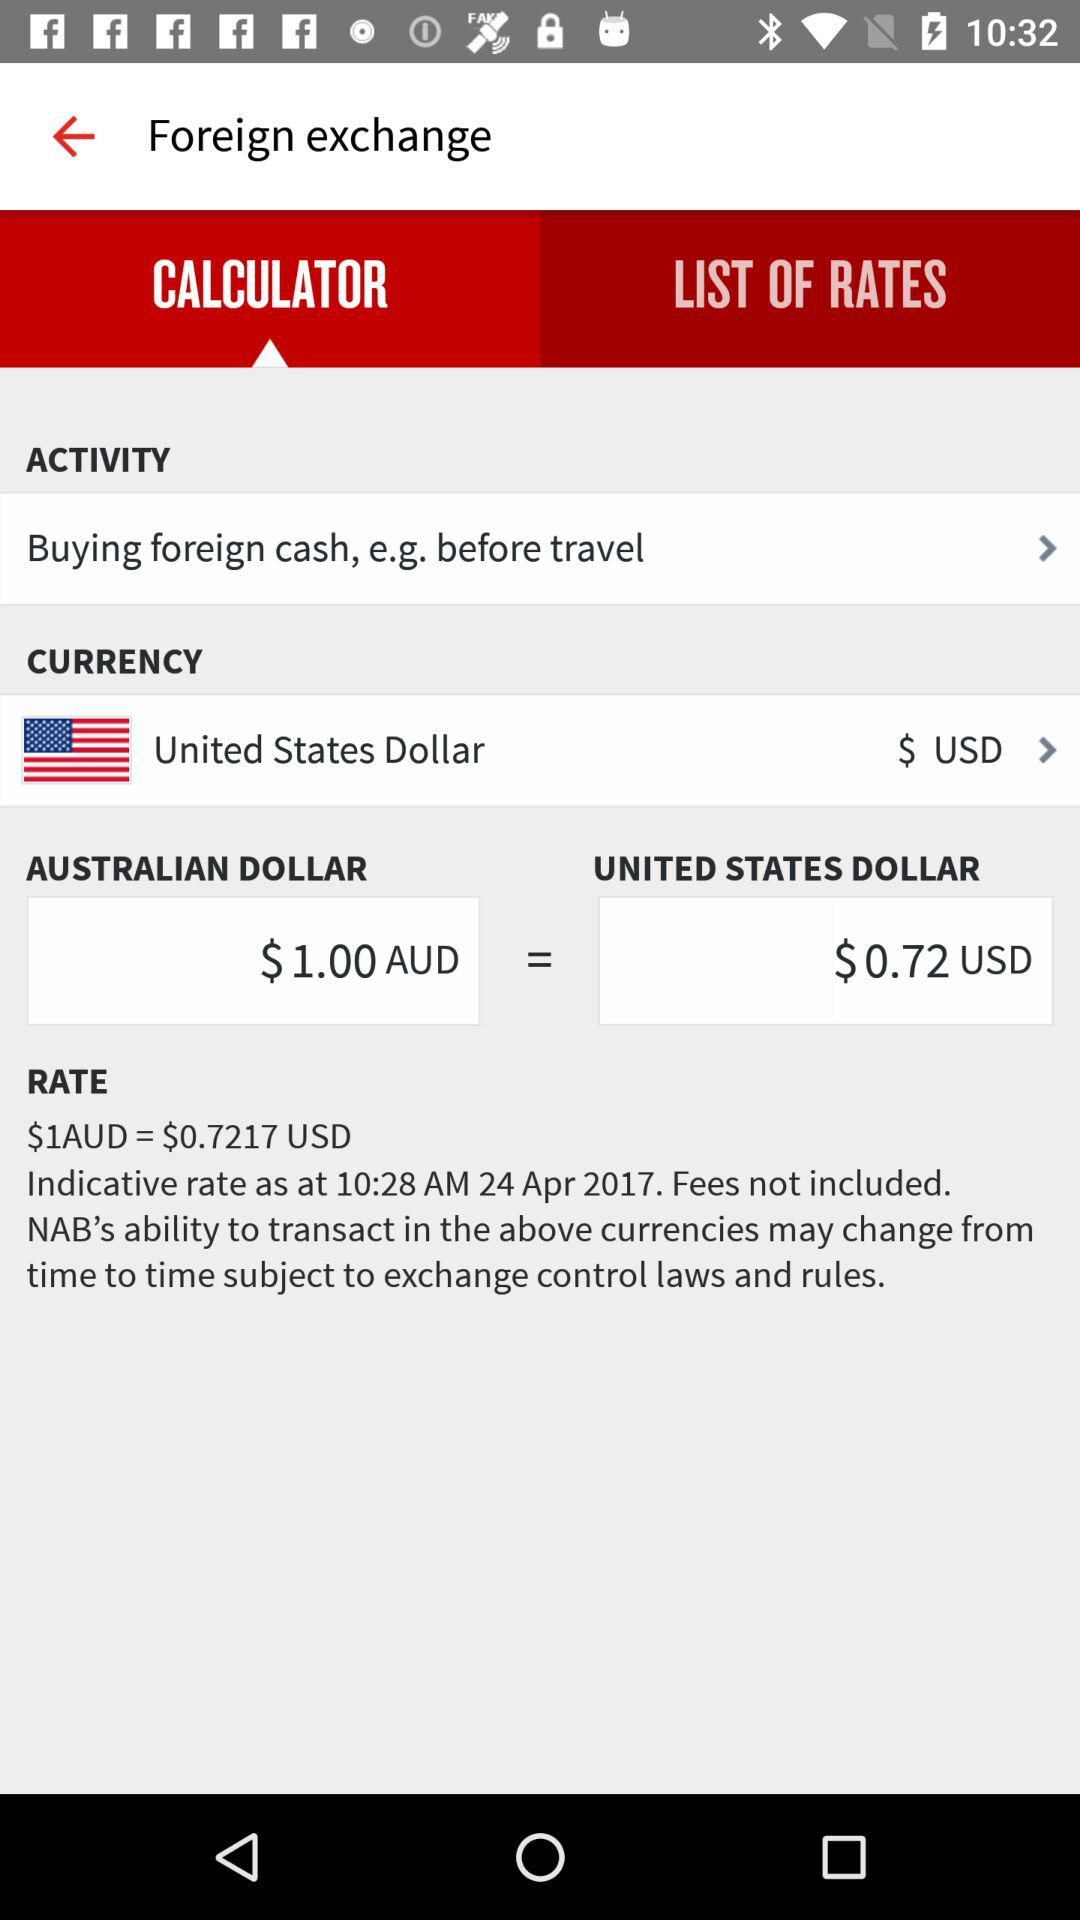How many USD are equal to 1 Australian dollar? 1 Australian dollar is equal to 0.7217 USD. 